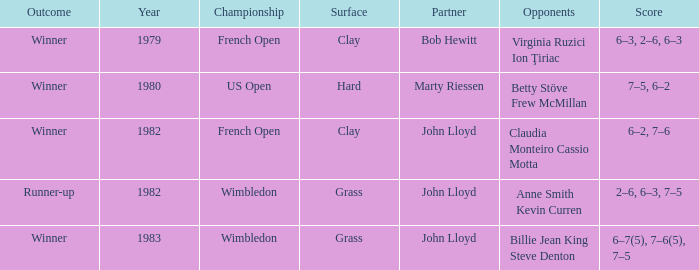What was the floor for events organized in 1983? Grass. 